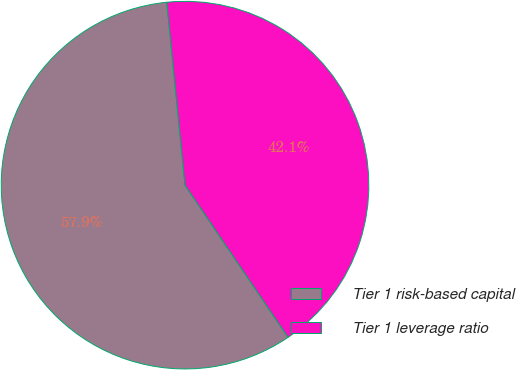Convert chart to OTSL. <chart><loc_0><loc_0><loc_500><loc_500><pie_chart><fcel>Tier 1 risk-based capital<fcel>Tier 1 leverage ratio<nl><fcel>57.89%<fcel>42.11%<nl></chart> 